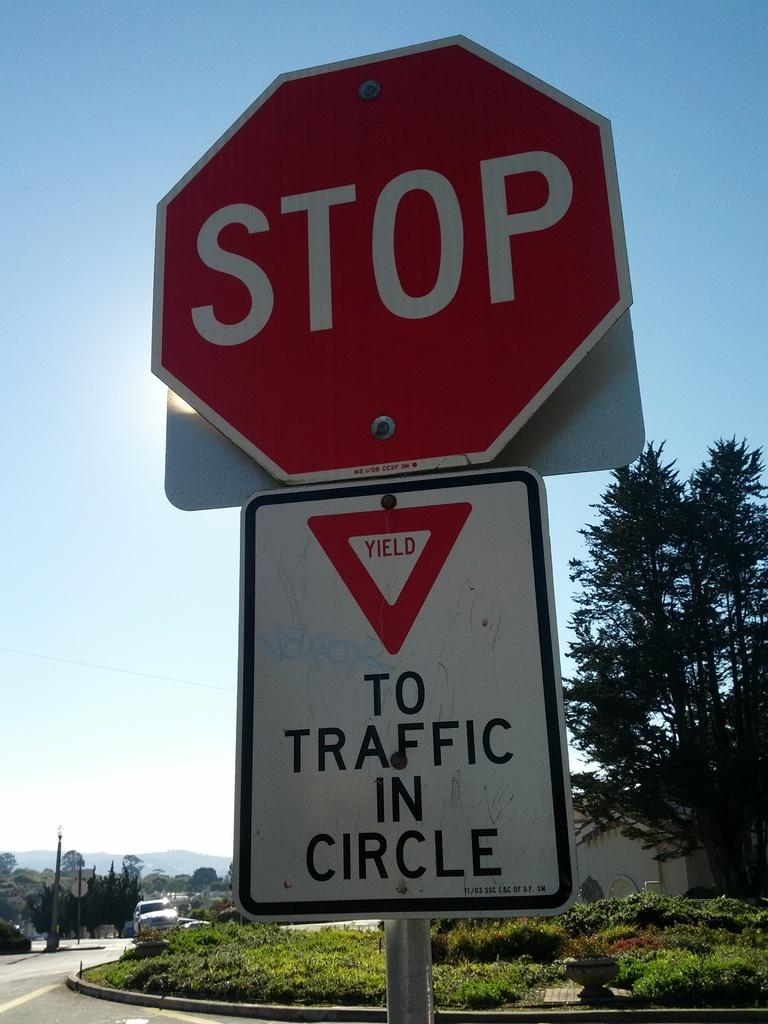<image>
Summarize the visual content of the image. A stop sign with a sign underneath with to traffic in circle written on it. 